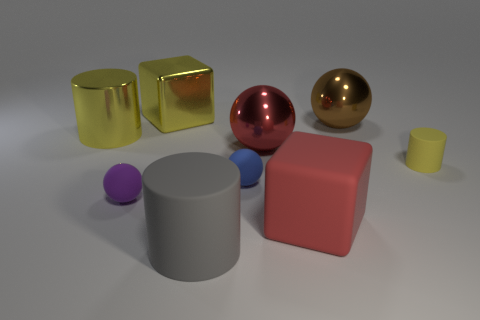There is a matte object that is the same color as the shiny cube; what size is it?
Make the answer very short. Small. Are there any blocks made of the same material as the brown ball?
Offer a very short reply. Yes. Does the cylinder on the right side of the tiny blue rubber ball have the same material as the large cylinder in front of the red block?
Give a very brief answer. Yes. What number of big blocks are there?
Ensure brevity in your answer.  2. What is the shape of the tiny matte object behind the tiny blue sphere?
Your answer should be very brief. Cylinder. How many other things are the same size as the red ball?
Provide a short and direct response. 5. There is a big yellow thing to the left of the big metal block; does it have the same shape as the brown metal thing that is behind the gray thing?
Keep it short and to the point. No. There is a red matte cube; what number of big metallic balls are in front of it?
Your answer should be compact. 0. There is a thing left of the purple thing; what color is it?
Make the answer very short. Yellow. What is the color of the large shiny thing that is the same shape as the large red rubber object?
Offer a very short reply. Yellow. 